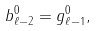<formula> <loc_0><loc_0><loc_500><loc_500>b ^ { 0 } _ { \ell - 2 } = g ^ { 0 } _ { \ell - 1 } ,</formula> 